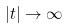<formula> <loc_0><loc_0><loc_500><loc_500>| t | \rightarrow \infty</formula> 